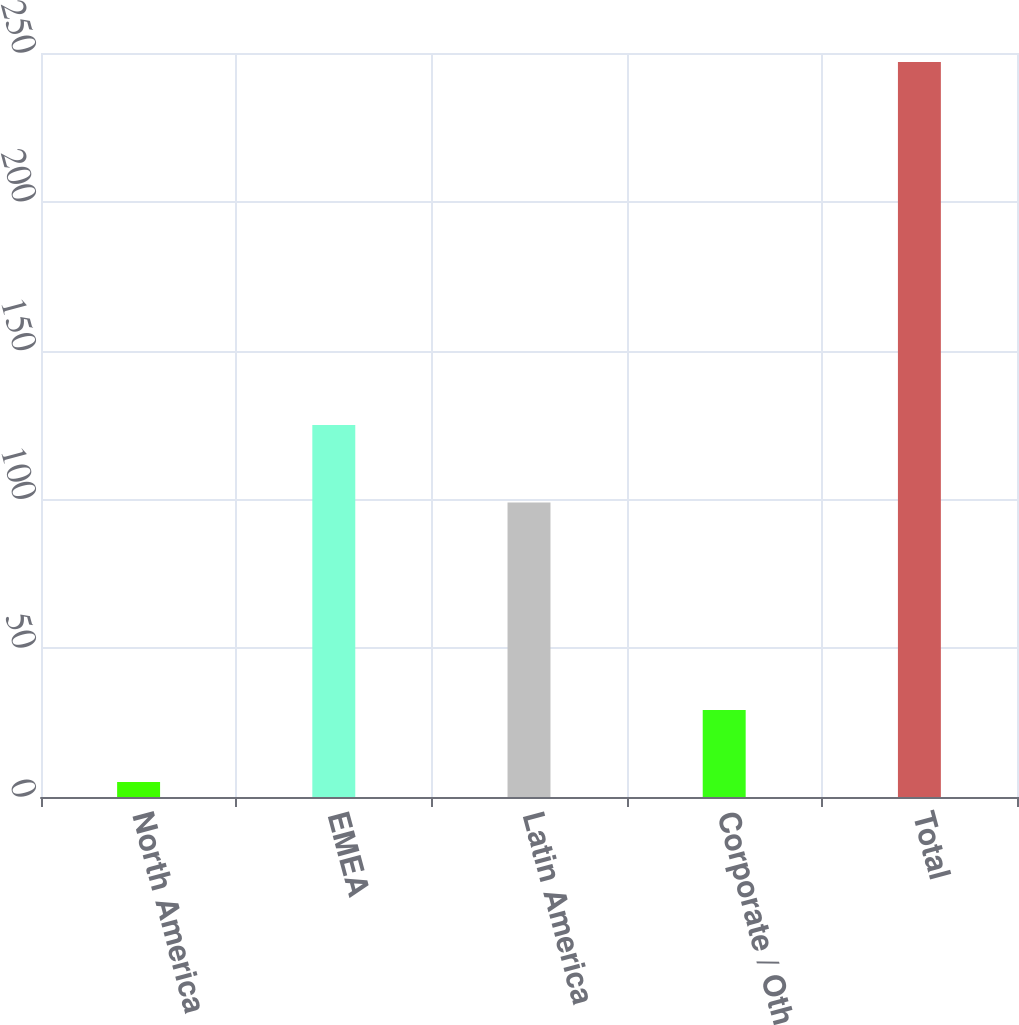<chart> <loc_0><loc_0><loc_500><loc_500><bar_chart><fcel>North America<fcel>EMEA<fcel>Latin America<fcel>Corporate / Other<fcel>Total<nl><fcel>5<fcel>125<fcel>99<fcel>29.2<fcel>247<nl></chart> 